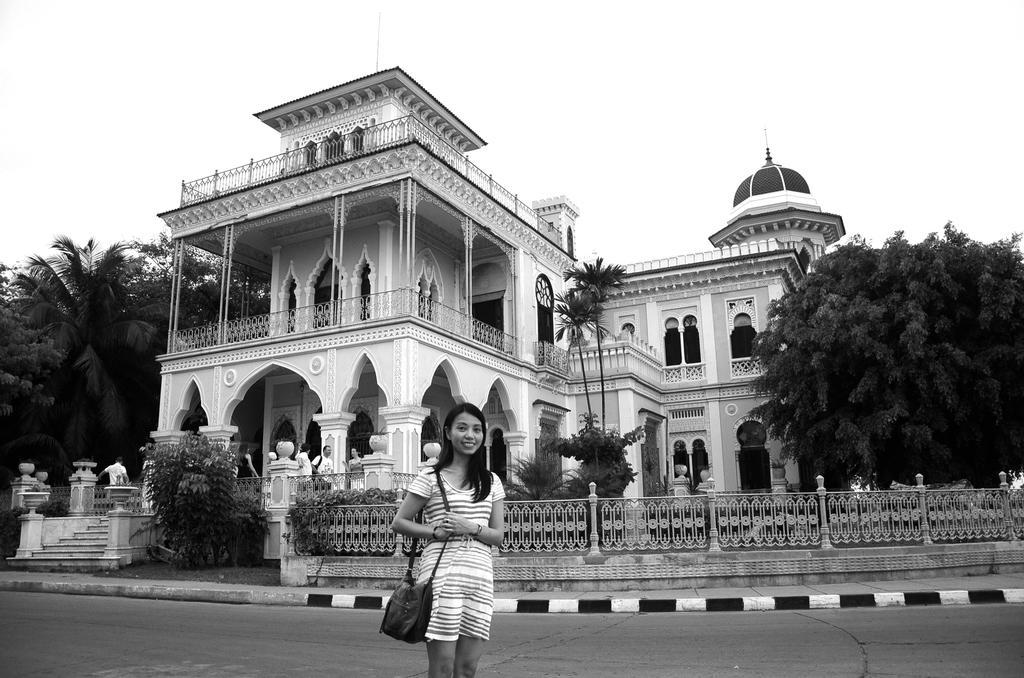Describe this image in one or two sentences. In this image there is the sky towards the top of the image, there is a building, there are two men and a woman standing, there are trees towards the left of the image, there is a tree towards the right of the image, there are staircase towards the left of the image, there is a fence towards the right of the image, there is a woman standing towards the bottom of the image, she is wearing a bag, there is road towards the bottom of the image. 